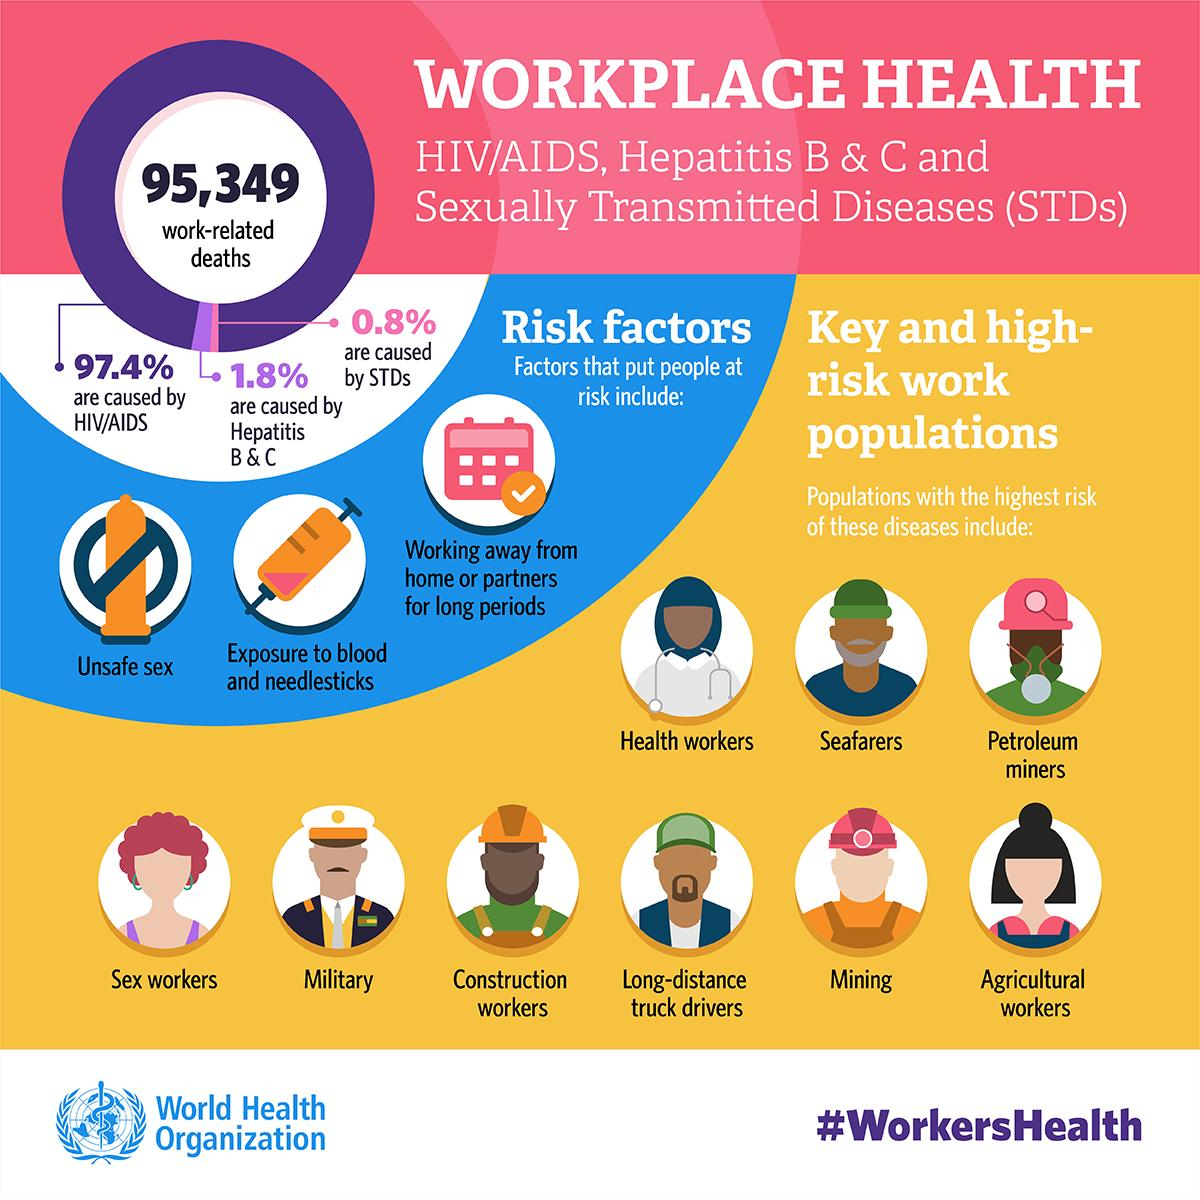Point out several critical features in this image. According to data, only 0.8% of work-related deaths are caused by STDs. HIV/AIDS has caused the highest percentage of work-related deaths. Hepatitis B and C are responsible for 1.8% of work-related deaths. Sexually transmitted diseases have caused the least percent of work-related deaths. Ninety-seven point four percent of work-related deaths are attributed to HIV/AIDS. 